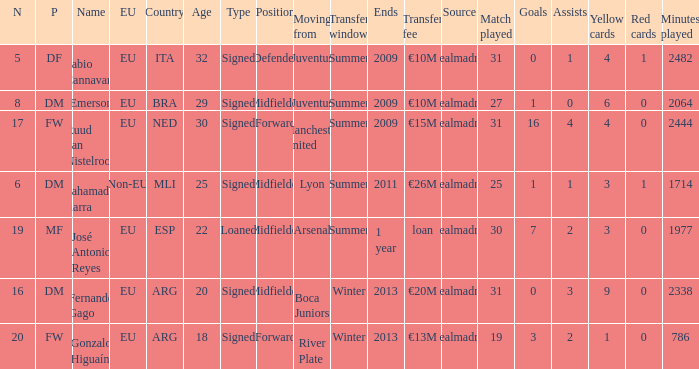What is the EU status of ESP? EU. 